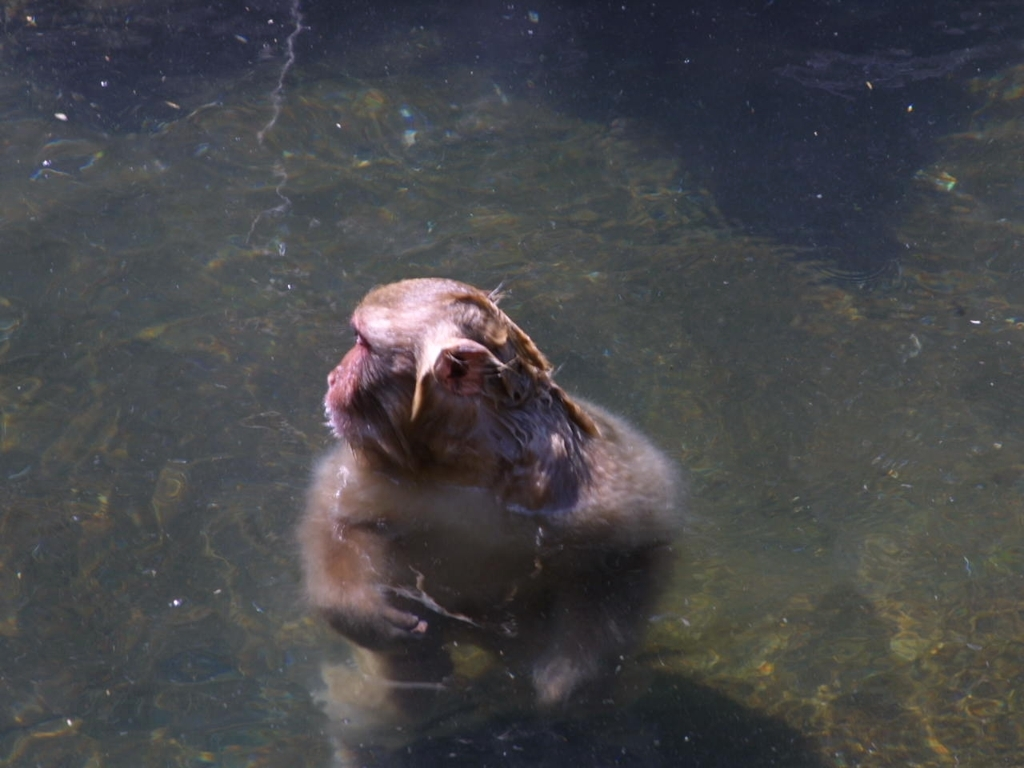Is this behavior typical for monkeys? Yes, monkeys often frequent bodies of water for various reasons such as searching for food, drinking, or regulating their body temperature. The specific behavior would depend on the species and the environmental context. 